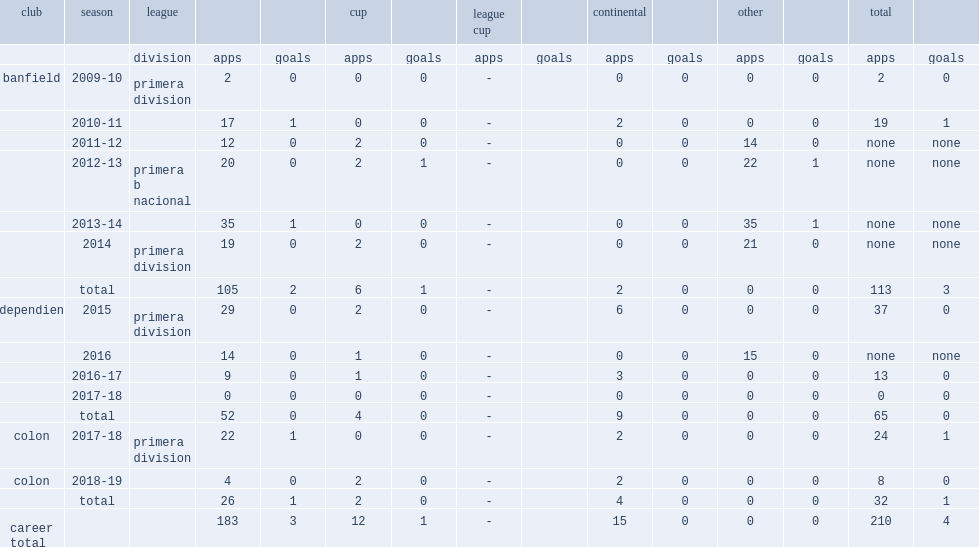What was the number of appearances made by gustavo for banfield in 2014? 19.0. 